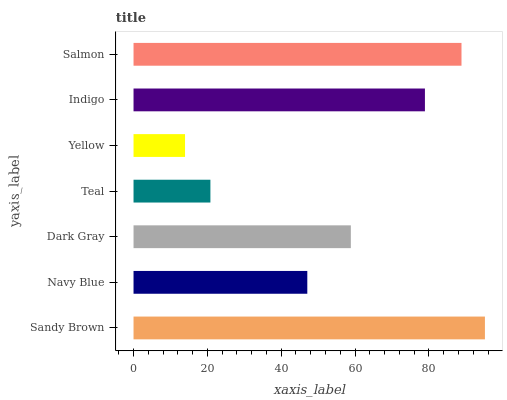Is Yellow the minimum?
Answer yes or no. Yes. Is Sandy Brown the maximum?
Answer yes or no. Yes. Is Navy Blue the minimum?
Answer yes or no. No. Is Navy Blue the maximum?
Answer yes or no. No. Is Sandy Brown greater than Navy Blue?
Answer yes or no. Yes. Is Navy Blue less than Sandy Brown?
Answer yes or no. Yes. Is Navy Blue greater than Sandy Brown?
Answer yes or no. No. Is Sandy Brown less than Navy Blue?
Answer yes or no. No. Is Dark Gray the high median?
Answer yes or no. Yes. Is Dark Gray the low median?
Answer yes or no. Yes. Is Sandy Brown the high median?
Answer yes or no. No. Is Teal the low median?
Answer yes or no. No. 